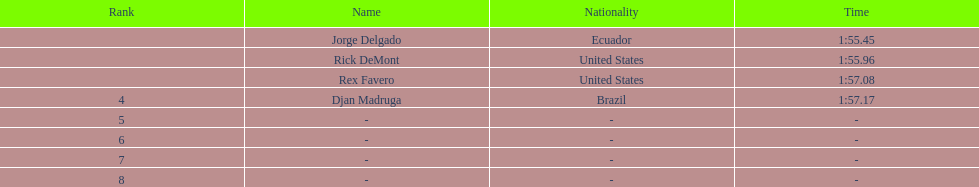How many ranked swimmers were from the united states? 2. 